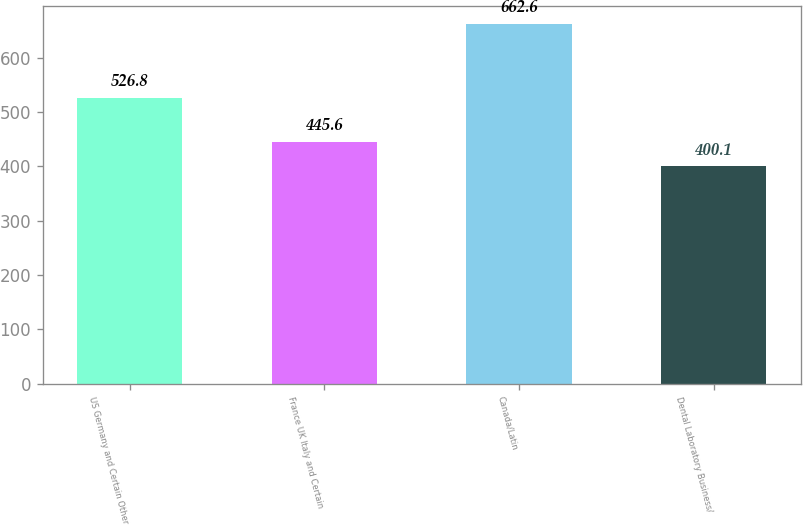Convert chart to OTSL. <chart><loc_0><loc_0><loc_500><loc_500><bar_chart><fcel>US Germany and Certain Other<fcel>France UK Italy and Certain<fcel>Canada/Latin<fcel>Dental Laboratory Business/<nl><fcel>526.8<fcel>445.6<fcel>662.6<fcel>400.1<nl></chart> 